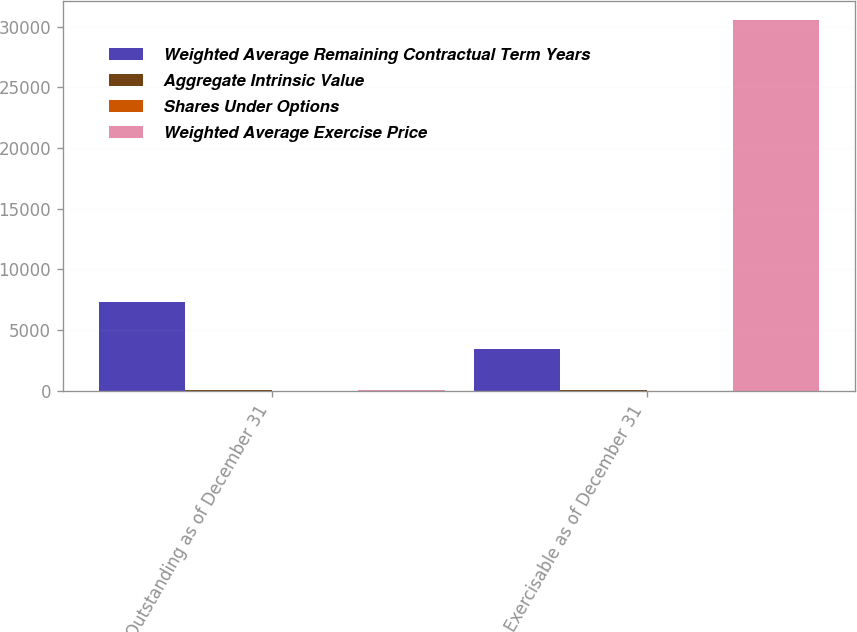Convert chart. <chart><loc_0><loc_0><loc_500><loc_500><stacked_bar_chart><ecel><fcel>Outstanding as of December 31<fcel>Exercisable as of December 31<nl><fcel>Weighted Average Remaining Contractual Term Years<fcel>7319<fcel>3430<nl><fcel>Aggregate Intrinsic Value<fcel>27.71<fcel>28.12<nl><fcel>Shares Under Options<fcel>6.6<fcel>5.1<nl><fcel>Weighted Average Exercise Price<fcel>28.12<fcel>30562<nl></chart> 